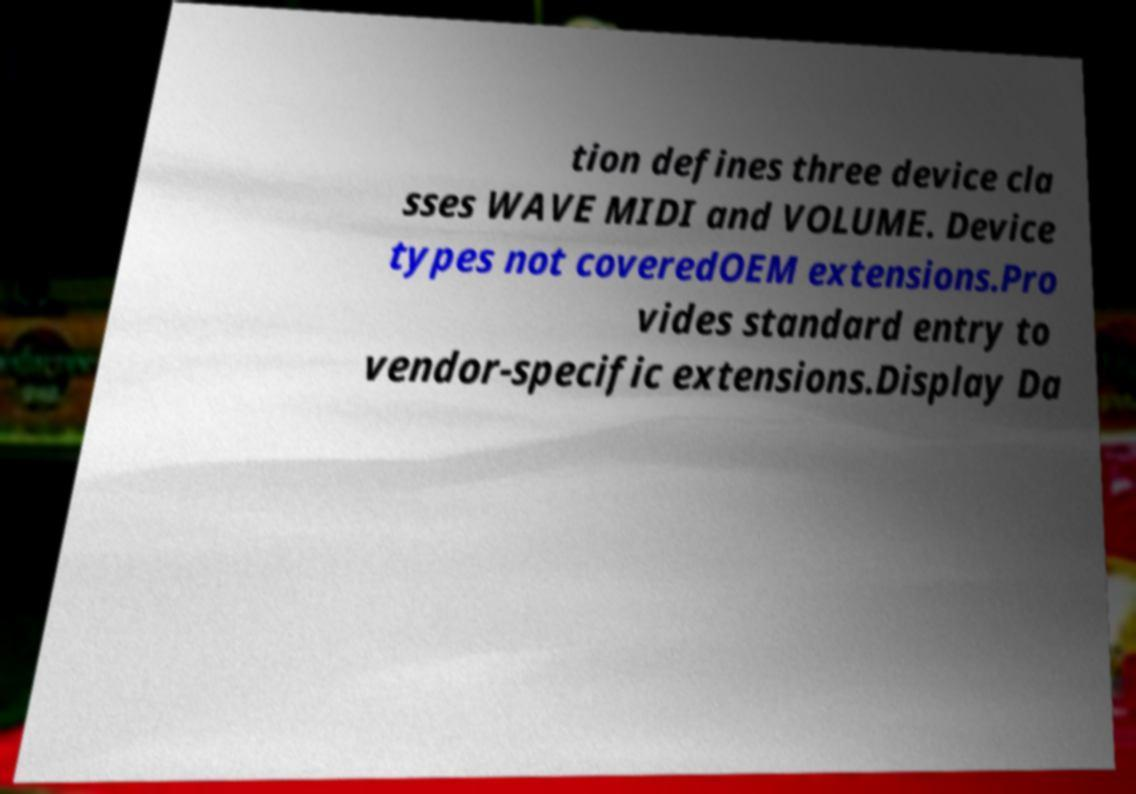Could you assist in decoding the text presented in this image and type it out clearly? tion defines three device cla sses WAVE MIDI and VOLUME. Device types not coveredOEM extensions.Pro vides standard entry to vendor-specific extensions.Display Da 